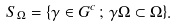Convert formula to latex. <formula><loc_0><loc_0><loc_500><loc_500>S _ { \Omega } = \{ \gamma \in G ^ { c } \, ; \, \gamma \Omega \subset \Omega \} .</formula> 